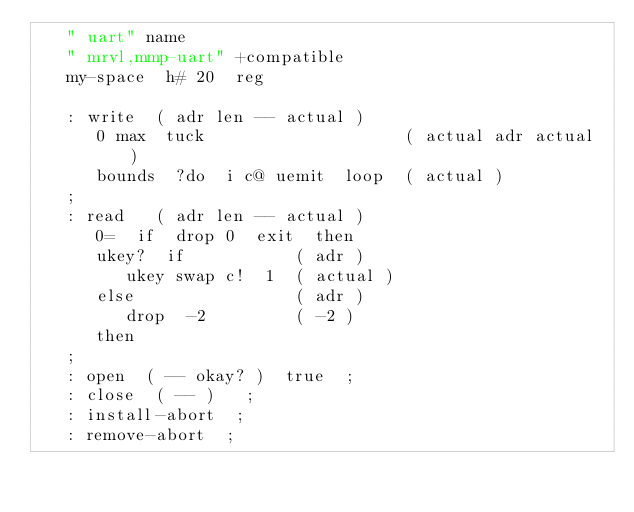Convert code to text. <code><loc_0><loc_0><loc_500><loc_500><_Forth_>   " uart" name
   " mrvl,mmp-uart" +compatible
   my-space  h# 20  reg

   : write  ( adr len -- actual )
      0 max  tuck                    ( actual adr actual )
      bounds  ?do  i c@ uemit  loop  ( actual )
   ;
   : read   ( adr len -- actual )
      0=  if  drop 0  exit  then
      ukey?  if           ( adr )
         ukey swap c!  1  ( actual )
      else                ( adr )
         drop  -2         ( -2 )
      then
   ;
   : open  ( -- okay? )  true  ;
   : close  ( -- )   ;
   : install-abort  ;
   : remove-abort  ;
</code> 